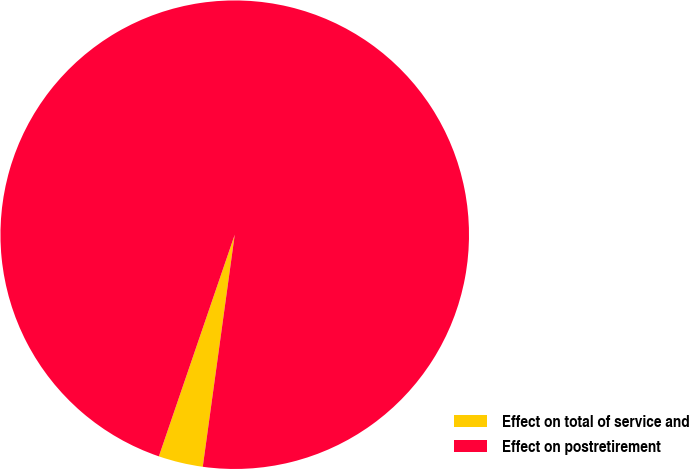Convert chart. <chart><loc_0><loc_0><loc_500><loc_500><pie_chart><fcel>Effect on total of service and<fcel>Effect on postretirement<nl><fcel>3.07%<fcel>96.93%<nl></chart> 